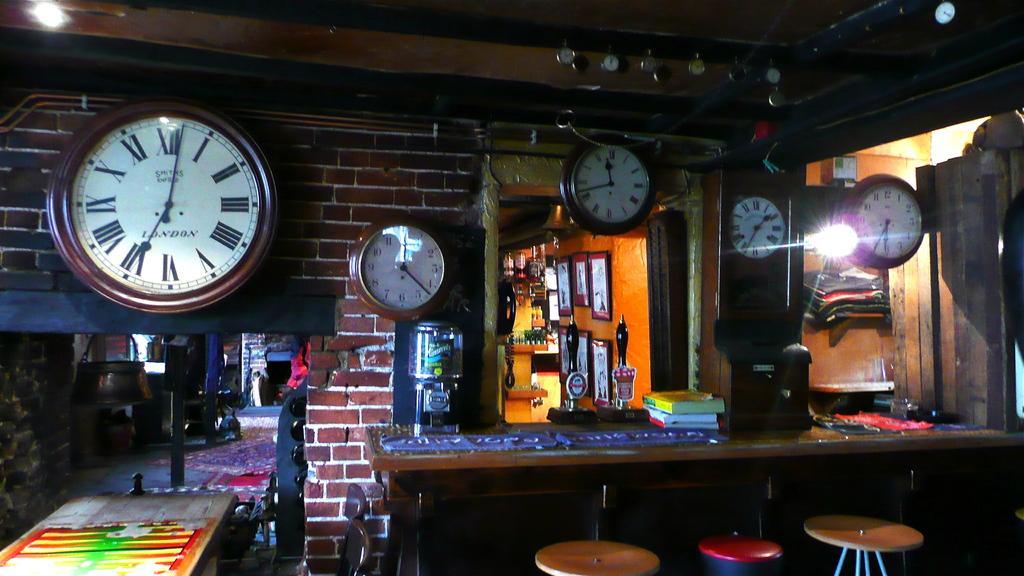In one or two sentences, can you explain what this image depicts? In this image we can see some clocks on the wall. On the left side of the image we can see a vessel and some chairs placed on the surface. In the foreground of the image we can see a container, some books and a clock placed on the table, we can also see some stools. In the right side of the image we can see some objects placed on racks. In the center of the image we can see some photo frames on the wall. 